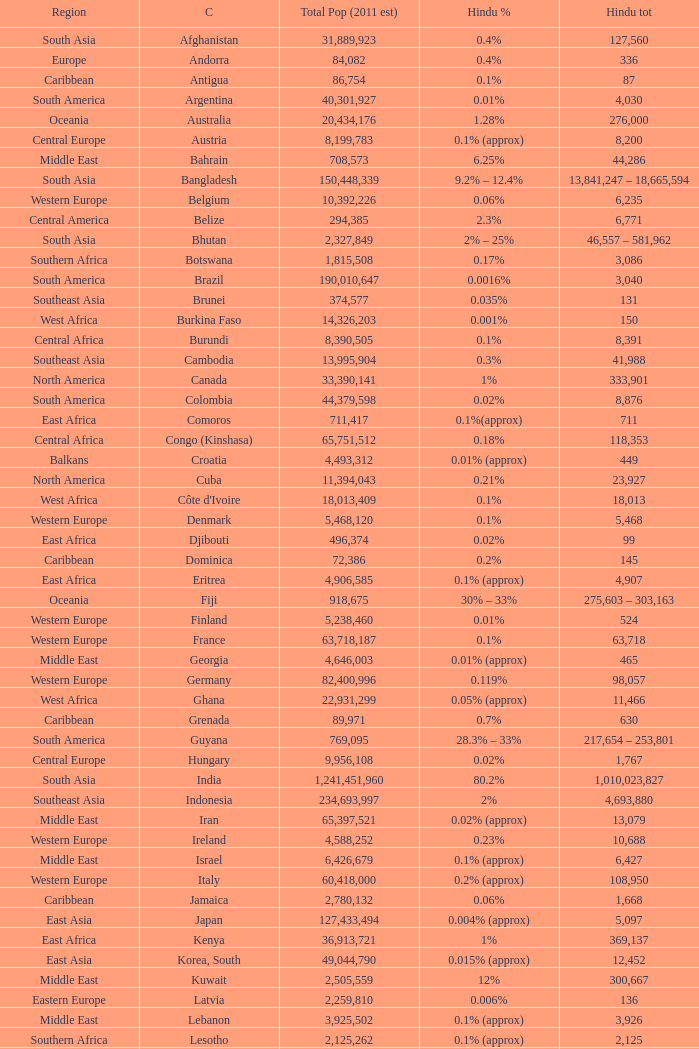Total Population (2011 est) larger than 30,262,610, and a Hindu total of 63,718 involves what country? France. 